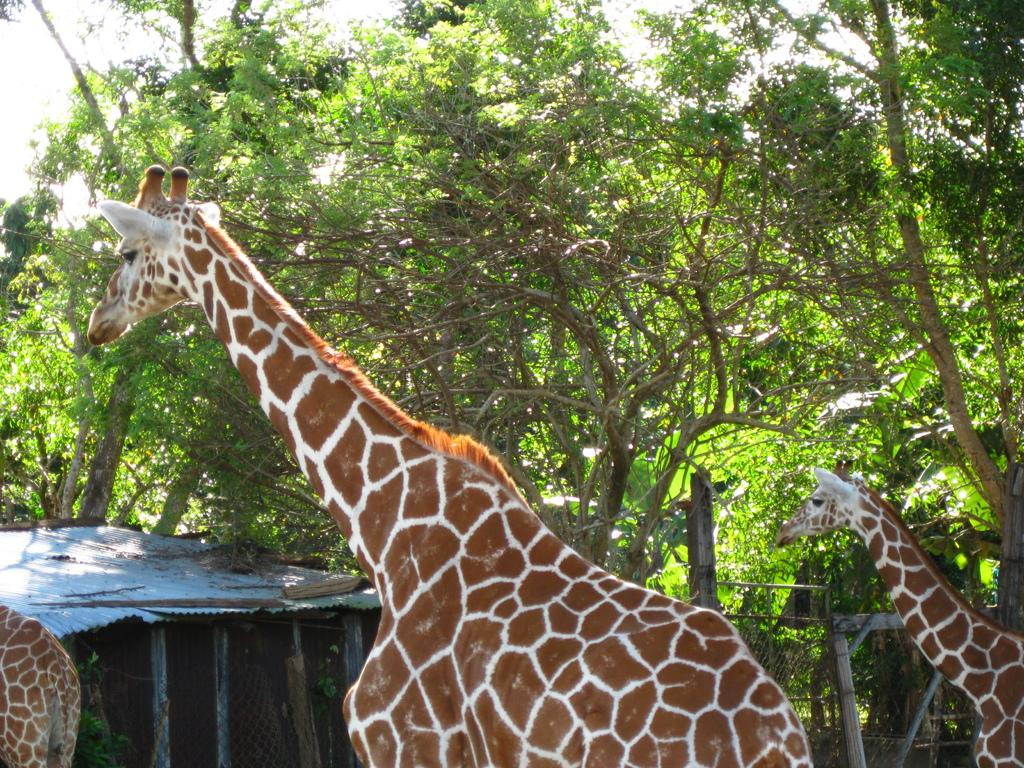What animals can be seen in the image? There are giraffes in the image. What type of structure is present in the image? There is a shed in the image. What can be seen in the background of the image? There are trees in the background of the image. What is visible at the top of the image? The sky is visible in the image. How many seeds can be seen on the giraffes in the image? There are no seeds present on the giraffes in the image. What type of frogs can be seen in the image? There are no frogs present in the image. 